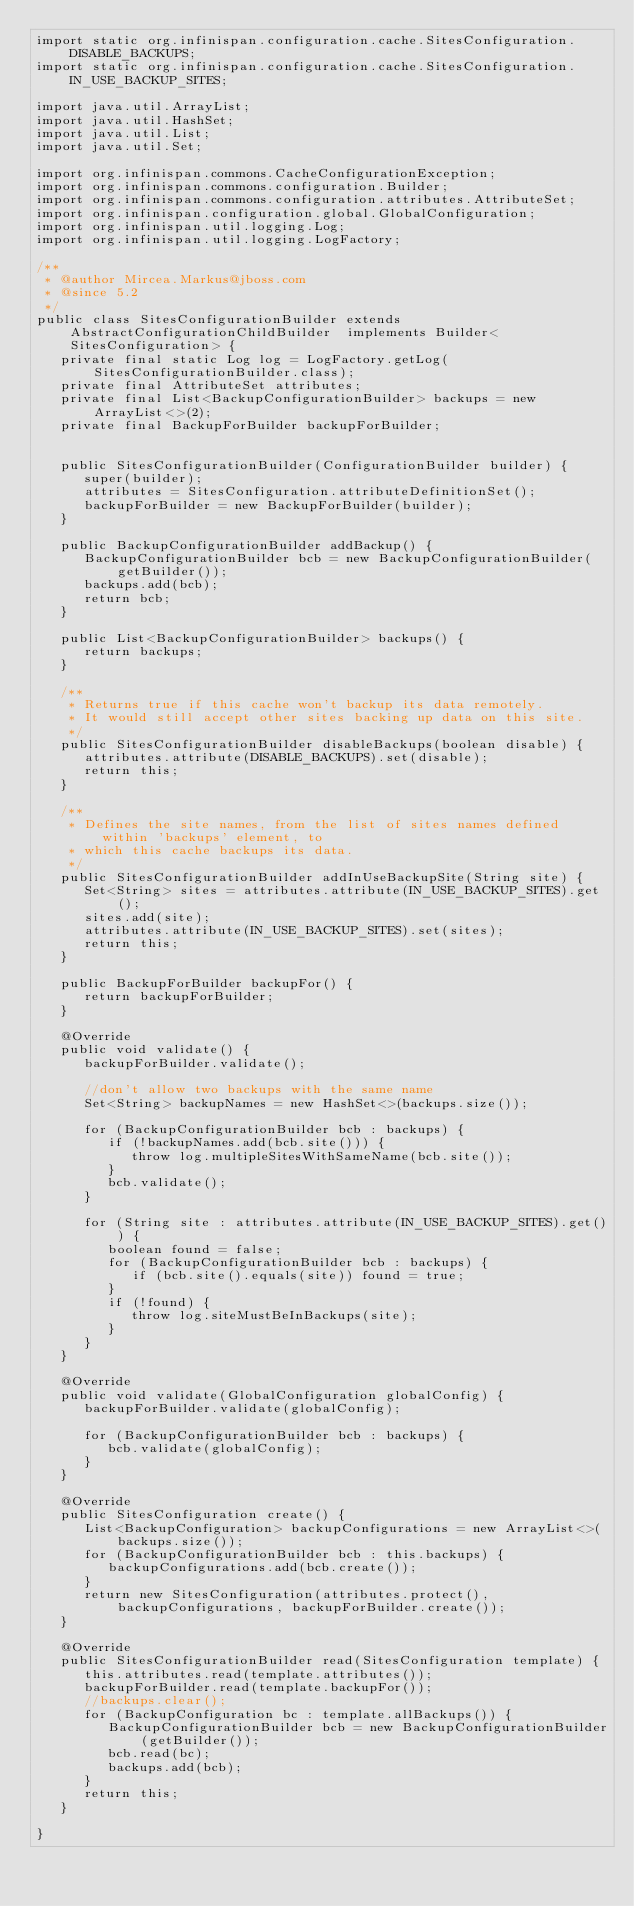Convert code to text. <code><loc_0><loc_0><loc_500><loc_500><_Java_>import static org.infinispan.configuration.cache.SitesConfiguration.DISABLE_BACKUPS;
import static org.infinispan.configuration.cache.SitesConfiguration.IN_USE_BACKUP_SITES;

import java.util.ArrayList;
import java.util.HashSet;
import java.util.List;
import java.util.Set;

import org.infinispan.commons.CacheConfigurationException;
import org.infinispan.commons.configuration.Builder;
import org.infinispan.commons.configuration.attributes.AttributeSet;
import org.infinispan.configuration.global.GlobalConfiguration;
import org.infinispan.util.logging.Log;
import org.infinispan.util.logging.LogFactory;

/**
 * @author Mircea.Markus@jboss.com
 * @since 5.2
 */
public class SitesConfigurationBuilder extends AbstractConfigurationChildBuilder  implements Builder<SitesConfiguration> {
   private final static Log log = LogFactory.getLog(SitesConfigurationBuilder.class);
   private final AttributeSet attributes;
   private final List<BackupConfigurationBuilder> backups = new ArrayList<>(2);
   private final BackupForBuilder backupForBuilder;


   public SitesConfigurationBuilder(ConfigurationBuilder builder) {
      super(builder);
      attributes = SitesConfiguration.attributeDefinitionSet();
      backupForBuilder = new BackupForBuilder(builder);
   }

   public BackupConfigurationBuilder addBackup() {
      BackupConfigurationBuilder bcb = new BackupConfigurationBuilder(getBuilder());
      backups.add(bcb);
      return bcb;
   }

   public List<BackupConfigurationBuilder> backups() {
      return backups;
   }

   /**
    * Returns true if this cache won't backup its data remotely.
    * It would still accept other sites backing up data on this site.
    */
   public SitesConfigurationBuilder disableBackups(boolean disable) {
      attributes.attribute(DISABLE_BACKUPS).set(disable);
      return this;
   }

   /**
    * Defines the site names, from the list of sites names defined within 'backups' element, to
    * which this cache backups its data.
    */
   public SitesConfigurationBuilder addInUseBackupSite(String site) {
      Set<String> sites = attributes.attribute(IN_USE_BACKUP_SITES).get();
      sites.add(site);
      attributes.attribute(IN_USE_BACKUP_SITES).set(sites);
      return this;
   }

   public BackupForBuilder backupFor() {
      return backupForBuilder;
   }

   @Override
   public void validate() {
      backupForBuilder.validate();

      //don't allow two backups with the same name
      Set<String> backupNames = new HashSet<>(backups.size());

      for (BackupConfigurationBuilder bcb : backups) {
         if (!backupNames.add(bcb.site())) {
            throw log.multipleSitesWithSameName(bcb.site());
         }
         bcb.validate();
      }

      for (String site : attributes.attribute(IN_USE_BACKUP_SITES).get()) {
         boolean found = false;
         for (BackupConfigurationBuilder bcb : backups) {
            if (bcb.site().equals(site)) found = true;
         }
         if (!found) {
            throw log.siteMustBeInBackups(site);
         }
      }
   }

   @Override
   public void validate(GlobalConfiguration globalConfig) {
      backupForBuilder.validate(globalConfig);

      for (BackupConfigurationBuilder bcb : backups) {
         bcb.validate(globalConfig);
      }
   }

   @Override
   public SitesConfiguration create() {
      List<BackupConfiguration> backupConfigurations = new ArrayList<>(backups.size());
      for (BackupConfigurationBuilder bcb : this.backups) {
         backupConfigurations.add(bcb.create());
      }
      return new SitesConfiguration(attributes.protect(), backupConfigurations, backupForBuilder.create());
   }

   @Override
   public SitesConfigurationBuilder read(SitesConfiguration template) {
      this.attributes.read(template.attributes());
      backupForBuilder.read(template.backupFor());
      //backups.clear();
      for (BackupConfiguration bc : template.allBackups()) {
         BackupConfigurationBuilder bcb = new BackupConfigurationBuilder(getBuilder());
         bcb.read(bc);
         backups.add(bcb);
      }
      return this;
   }

}
</code> 